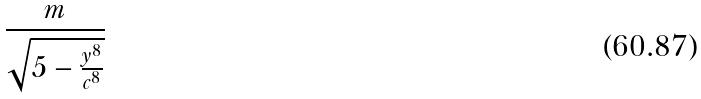<formula> <loc_0><loc_0><loc_500><loc_500>\frac { m } { \sqrt { 5 - \frac { y ^ { 8 } } { c ^ { 8 } } } }</formula> 